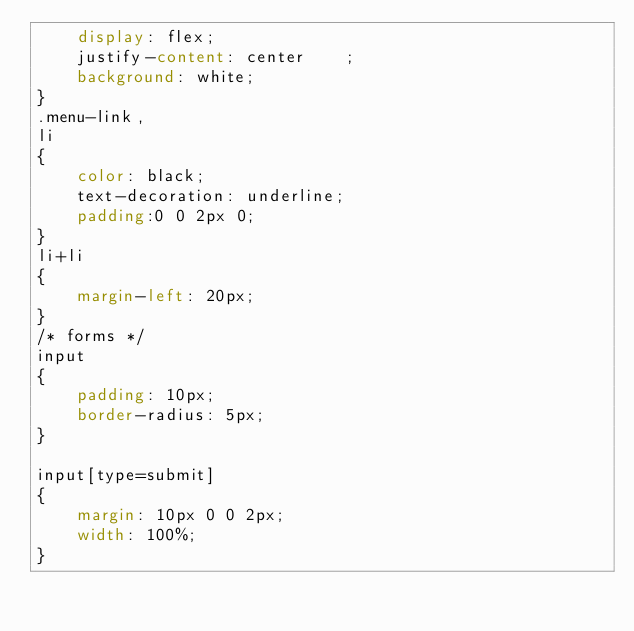<code> <loc_0><loc_0><loc_500><loc_500><_CSS_>    display: flex;
    justify-content: center    ;
    background: white;
}
.menu-link,
li
{
    color: black;
    text-decoration: underline;
    padding:0 0 2px 0;
}
li+li
{
    margin-left: 20px;
}
/* forms */
input
{
    padding: 10px;
    border-radius: 5px;
}

input[type=submit] 
{
    margin: 10px 0 0 2px;
    width: 100%;
}
</code> 